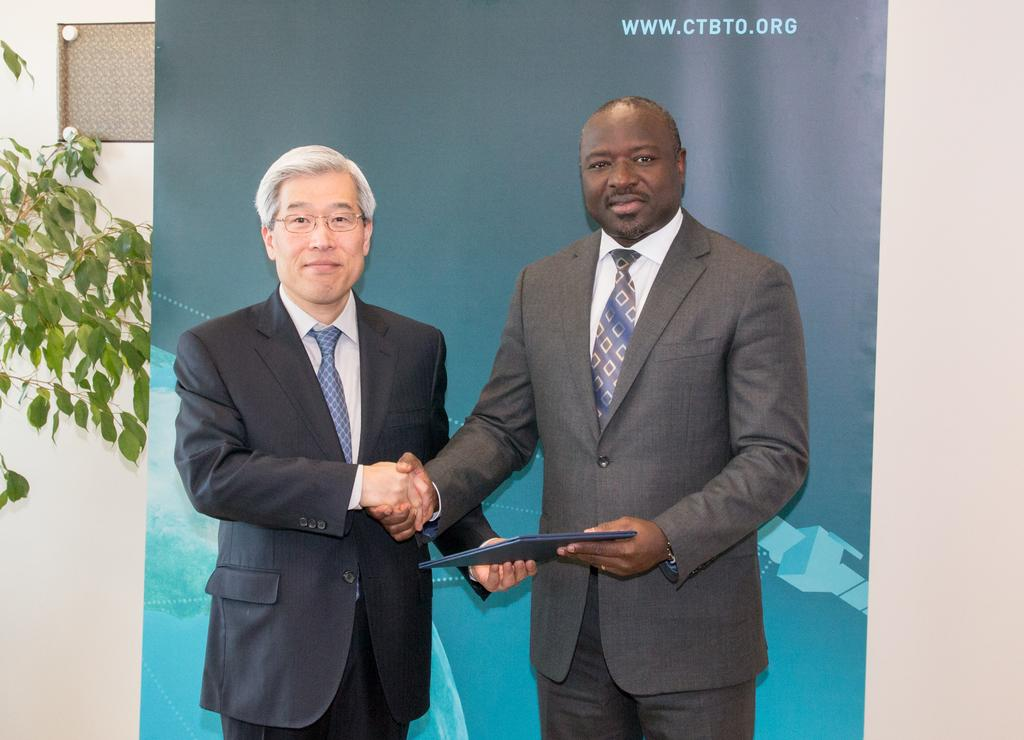How many people are in the image? There are two persons in the image. What are the persons wearing? Both persons are wearing coats and ties. What is one person holding in his hand? One person is holding a file in his hand. What can be seen in the background of the image? There is a banner with text and a plant in the background. How many balls can be seen in the image? There are no balls present in the image. Is there a stranger in the image? The image only shows two persons, both of whom are wearing coats and ties, so there is no stranger depicted. 